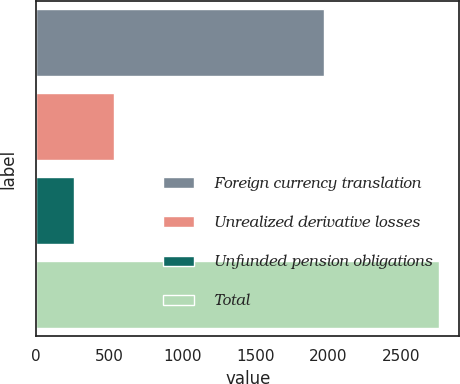Convert chart to OTSL. <chart><loc_0><loc_0><loc_500><loc_500><bar_chart><fcel>Foreign currency translation<fcel>Unrealized derivative losses<fcel>Unfunded pension obligations<fcel>Total<nl><fcel>1967<fcel>534<fcel>257<fcel>2758<nl></chart> 